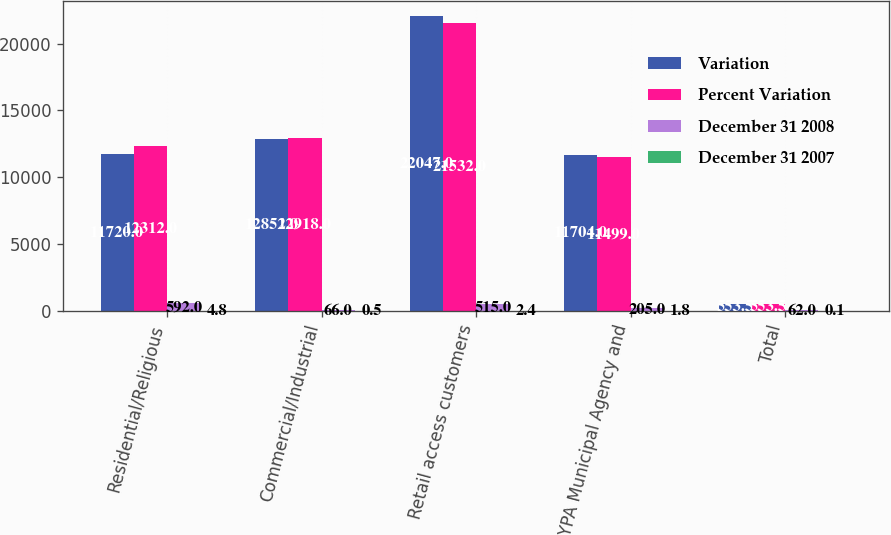Convert chart. <chart><loc_0><loc_0><loc_500><loc_500><stacked_bar_chart><ecel><fcel>Residential/Religious<fcel>Commercial/Industrial<fcel>Retail access customers<fcel>NYPA Municipal Agency and<fcel>Total<nl><fcel>Variation<fcel>11720<fcel>12852<fcel>22047<fcel>11704<fcel>553.5<nl><fcel>Percent Variation<fcel>12312<fcel>12918<fcel>21532<fcel>11499<fcel>553.5<nl><fcel>December 31 2008<fcel>592<fcel>66<fcel>515<fcel>205<fcel>62<nl><fcel>December 31 2007<fcel>4.8<fcel>0.5<fcel>2.4<fcel>1.8<fcel>0.1<nl></chart> 